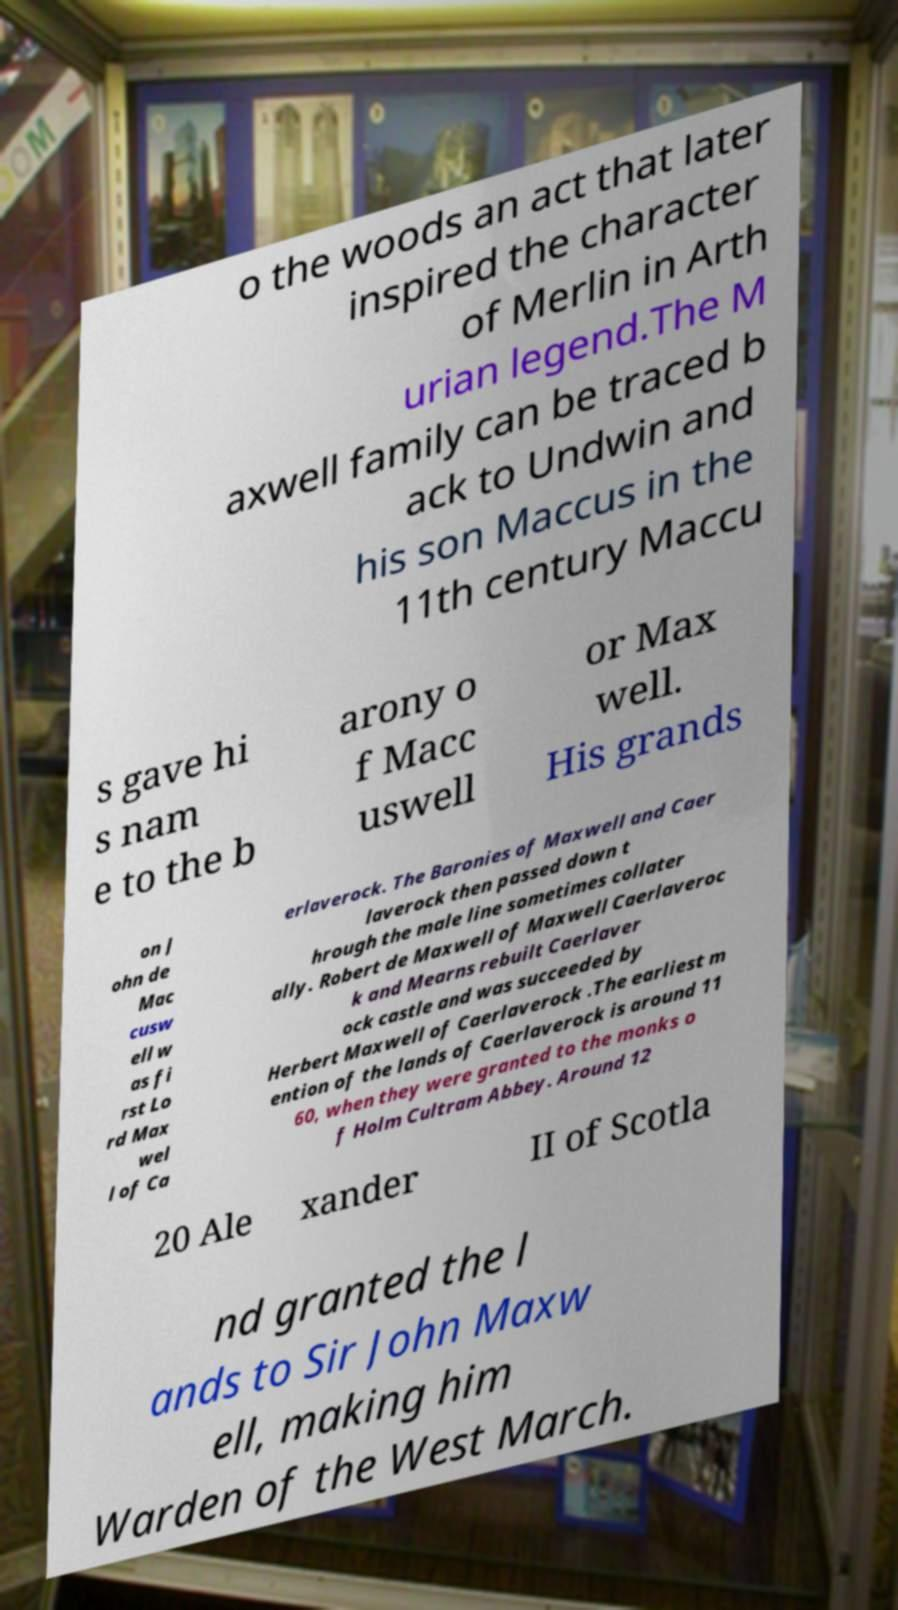For documentation purposes, I need the text within this image transcribed. Could you provide that? o the woods an act that later inspired the character of Merlin in Arth urian legend.The M axwell family can be traced b ack to Undwin and his son Maccus in the 11th century Maccu s gave hi s nam e to the b arony o f Macc uswell or Max well. His grands on J ohn de Mac cusw ell w as fi rst Lo rd Max wel l of Ca erlaverock. The Baronies of Maxwell and Caer laverock then passed down t hrough the male line sometimes collater ally. Robert de Maxwell of Maxwell Caerlaveroc k and Mearns rebuilt Caerlaver ock castle and was succeeded by Herbert Maxwell of Caerlaverock .The earliest m ention of the lands of Caerlaverock is around 11 60, when they were granted to the monks o f Holm Cultram Abbey. Around 12 20 Ale xander II of Scotla nd granted the l ands to Sir John Maxw ell, making him Warden of the West March. 